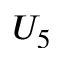Convert formula to latex. <formula><loc_0><loc_0><loc_500><loc_500>U _ { 5 }</formula> 